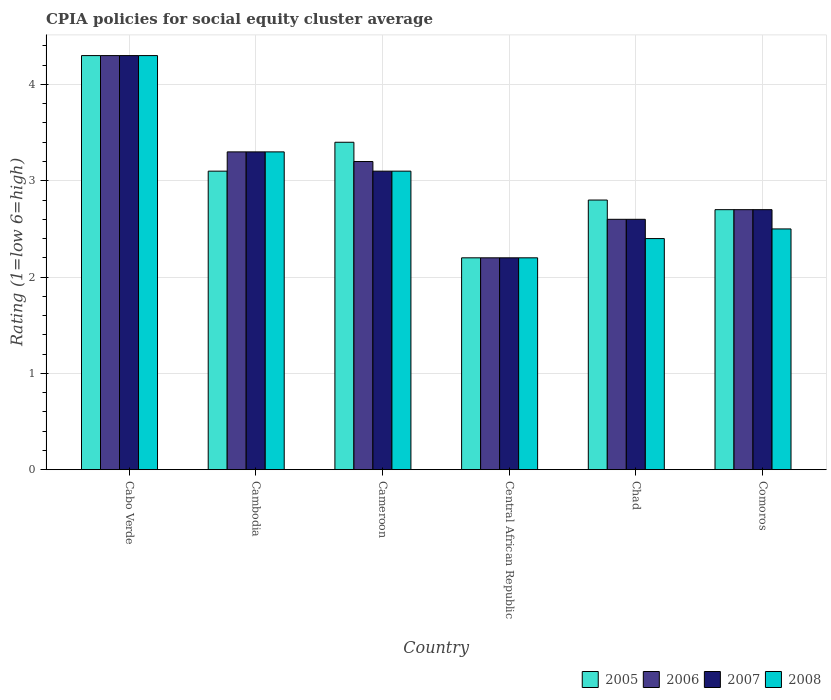How many different coloured bars are there?
Provide a succinct answer. 4. How many groups of bars are there?
Provide a succinct answer. 6. Are the number of bars on each tick of the X-axis equal?
Your response must be concise. Yes. How many bars are there on the 2nd tick from the left?
Provide a succinct answer. 4. What is the label of the 6th group of bars from the left?
Keep it short and to the point. Comoros. Across all countries, what is the maximum CPIA rating in 2007?
Provide a succinct answer. 4.3. Across all countries, what is the minimum CPIA rating in 2008?
Keep it short and to the point. 2.2. In which country was the CPIA rating in 2005 maximum?
Your answer should be very brief. Cabo Verde. In which country was the CPIA rating in 2007 minimum?
Provide a succinct answer. Central African Republic. What is the difference between the CPIA rating in 2005 in Cabo Verde and that in Cambodia?
Give a very brief answer. 1.2. What is the difference between the CPIA rating in 2007 in Central African Republic and the CPIA rating in 2008 in Cambodia?
Give a very brief answer. -1.1. What is the average CPIA rating in 2007 per country?
Offer a terse response. 3.03. What is the difference between the CPIA rating of/in 2008 and CPIA rating of/in 2006 in Cameroon?
Provide a succinct answer. -0.1. What is the ratio of the CPIA rating in 2008 in Cambodia to that in Cameroon?
Your response must be concise. 1.06. What is the difference between the highest and the second highest CPIA rating in 2006?
Make the answer very short. -0.1. What is the difference between the highest and the lowest CPIA rating in 2008?
Offer a terse response. 2.1. In how many countries, is the CPIA rating in 2008 greater than the average CPIA rating in 2008 taken over all countries?
Offer a terse response. 3. Is the sum of the CPIA rating in 2007 in Cabo Verde and Cameroon greater than the maximum CPIA rating in 2005 across all countries?
Provide a short and direct response. Yes. Is it the case that in every country, the sum of the CPIA rating in 2007 and CPIA rating in 2006 is greater than the sum of CPIA rating in 2005 and CPIA rating in 2008?
Give a very brief answer. No. What does the 4th bar from the left in Cabo Verde represents?
Offer a terse response. 2008. Are all the bars in the graph horizontal?
Make the answer very short. No. What is the difference between two consecutive major ticks on the Y-axis?
Your response must be concise. 1. Where does the legend appear in the graph?
Provide a succinct answer. Bottom right. What is the title of the graph?
Provide a short and direct response. CPIA policies for social equity cluster average. Does "1966" appear as one of the legend labels in the graph?
Ensure brevity in your answer.  No. What is the label or title of the X-axis?
Your answer should be compact. Country. What is the Rating (1=low 6=high) of 2006 in Cabo Verde?
Your answer should be very brief. 4.3. What is the Rating (1=low 6=high) of 2006 in Cambodia?
Provide a short and direct response. 3.3. What is the Rating (1=low 6=high) in 2007 in Cambodia?
Your answer should be very brief. 3.3. What is the Rating (1=low 6=high) in 2008 in Cameroon?
Your answer should be compact. 3.1. What is the Rating (1=low 6=high) of 2005 in Central African Republic?
Your response must be concise. 2.2. What is the Rating (1=low 6=high) of 2006 in Central African Republic?
Offer a terse response. 2.2. What is the Rating (1=low 6=high) of 2005 in Chad?
Your answer should be compact. 2.8. What is the Rating (1=low 6=high) in 2006 in Chad?
Keep it short and to the point. 2.6. What is the Rating (1=low 6=high) in 2007 in Comoros?
Your answer should be compact. 2.7. What is the Rating (1=low 6=high) of 2008 in Comoros?
Your answer should be very brief. 2.5. Across all countries, what is the maximum Rating (1=low 6=high) in 2005?
Your answer should be compact. 4.3. Across all countries, what is the maximum Rating (1=low 6=high) of 2006?
Your response must be concise. 4.3. Across all countries, what is the maximum Rating (1=low 6=high) in 2007?
Your answer should be very brief. 4.3. Across all countries, what is the maximum Rating (1=low 6=high) in 2008?
Your answer should be very brief. 4.3. Across all countries, what is the minimum Rating (1=low 6=high) in 2005?
Provide a short and direct response. 2.2. Across all countries, what is the minimum Rating (1=low 6=high) in 2006?
Your response must be concise. 2.2. Across all countries, what is the minimum Rating (1=low 6=high) in 2007?
Your answer should be compact. 2.2. What is the total Rating (1=low 6=high) in 2005 in the graph?
Offer a terse response. 18.5. What is the total Rating (1=low 6=high) in 2006 in the graph?
Offer a very short reply. 18.3. What is the difference between the Rating (1=low 6=high) of 2006 in Cabo Verde and that in Cambodia?
Offer a very short reply. 1. What is the difference between the Rating (1=low 6=high) of 2007 in Cabo Verde and that in Cambodia?
Give a very brief answer. 1. What is the difference between the Rating (1=low 6=high) in 2005 in Cabo Verde and that in Cameroon?
Ensure brevity in your answer.  0.9. What is the difference between the Rating (1=low 6=high) of 2006 in Cabo Verde and that in Cameroon?
Your answer should be compact. 1.1. What is the difference between the Rating (1=low 6=high) in 2008 in Cabo Verde and that in Cameroon?
Give a very brief answer. 1.2. What is the difference between the Rating (1=low 6=high) in 2005 in Cabo Verde and that in Central African Republic?
Your answer should be very brief. 2.1. What is the difference between the Rating (1=low 6=high) of 2006 in Cabo Verde and that in Central African Republic?
Give a very brief answer. 2.1. What is the difference between the Rating (1=low 6=high) of 2007 in Cabo Verde and that in Central African Republic?
Provide a short and direct response. 2.1. What is the difference between the Rating (1=low 6=high) in 2005 in Cabo Verde and that in Chad?
Your answer should be compact. 1.5. What is the difference between the Rating (1=low 6=high) of 2007 in Cabo Verde and that in Chad?
Provide a succinct answer. 1.7. What is the difference between the Rating (1=low 6=high) of 2008 in Cabo Verde and that in Chad?
Your answer should be compact. 1.9. What is the difference between the Rating (1=low 6=high) of 2005 in Cabo Verde and that in Comoros?
Offer a very short reply. 1.6. What is the difference between the Rating (1=low 6=high) of 2006 in Cabo Verde and that in Comoros?
Give a very brief answer. 1.6. What is the difference between the Rating (1=low 6=high) in 2007 in Cabo Verde and that in Comoros?
Your answer should be very brief. 1.6. What is the difference between the Rating (1=low 6=high) of 2008 in Cabo Verde and that in Comoros?
Provide a short and direct response. 1.8. What is the difference between the Rating (1=low 6=high) of 2007 in Cambodia and that in Cameroon?
Provide a short and direct response. 0.2. What is the difference between the Rating (1=low 6=high) in 2007 in Cambodia and that in Central African Republic?
Keep it short and to the point. 1.1. What is the difference between the Rating (1=low 6=high) of 2008 in Cambodia and that in Central African Republic?
Keep it short and to the point. 1.1. What is the difference between the Rating (1=low 6=high) in 2008 in Cambodia and that in Chad?
Offer a terse response. 0.9. What is the difference between the Rating (1=low 6=high) in 2005 in Cambodia and that in Comoros?
Give a very brief answer. 0.4. What is the difference between the Rating (1=low 6=high) in 2007 in Cambodia and that in Comoros?
Provide a succinct answer. 0.6. What is the difference between the Rating (1=low 6=high) of 2005 in Cameroon and that in Central African Republic?
Offer a terse response. 1.2. What is the difference between the Rating (1=low 6=high) in 2006 in Cameroon and that in Central African Republic?
Ensure brevity in your answer.  1. What is the difference between the Rating (1=low 6=high) in 2005 in Cameroon and that in Chad?
Offer a terse response. 0.6. What is the difference between the Rating (1=low 6=high) in 2008 in Cameroon and that in Chad?
Your answer should be compact. 0.7. What is the difference between the Rating (1=low 6=high) of 2005 in Cameroon and that in Comoros?
Provide a succinct answer. 0.7. What is the difference between the Rating (1=low 6=high) in 2006 in Cameroon and that in Comoros?
Your response must be concise. 0.5. What is the difference between the Rating (1=low 6=high) in 2008 in Cameroon and that in Comoros?
Your answer should be very brief. 0.6. What is the difference between the Rating (1=low 6=high) in 2006 in Central African Republic and that in Chad?
Offer a terse response. -0.4. What is the difference between the Rating (1=low 6=high) in 2007 in Central African Republic and that in Chad?
Make the answer very short. -0.4. What is the difference between the Rating (1=low 6=high) in 2006 in Central African Republic and that in Comoros?
Your response must be concise. -0.5. What is the difference between the Rating (1=low 6=high) in 2007 in Central African Republic and that in Comoros?
Provide a short and direct response. -0.5. What is the difference between the Rating (1=low 6=high) in 2008 in Central African Republic and that in Comoros?
Provide a succinct answer. -0.3. What is the difference between the Rating (1=low 6=high) in 2005 in Chad and that in Comoros?
Make the answer very short. 0.1. What is the difference between the Rating (1=low 6=high) in 2006 in Cabo Verde and the Rating (1=low 6=high) in 2007 in Cambodia?
Keep it short and to the point. 1. What is the difference between the Rating (1=low 6=high) of 2007 in Cabo Verde and the Rating (1=low 6=high) of 2008 in Cambodia?
Your answer should be very brief. 1. What is the difference between the Rating (1=low 6=high) in 2006 in Cabo Verde and the Rating (1=low 6=high) in 2007 in Cameroon?
Offer a very short reply. 1.2. What is the difference between the Rating (1=low 6=high) of 2005 in Cabo Verde and the Rating (1=low 6=high) of 2006 in Central African Republic?
Offer a terse response. 2.1. What is the difference between the Rating (1=low 6=high) in 2006 in Cabo Verde and the Rating (1=low 6=high) in 2007 in Central African Republic?
Offer a terse response. 2.1. What is the difference between the Rating (1=low 6=high) of 2005 in Cabo Verde and the Rating (1=low 6=high) of 2008 in Chad?
Your answer should be very brief. 1.9. What is the difference between the Rating (1=low 6=high) of 2006 in Cabo Verde and the Rating (1=low 6=high) of 2007 in Chad?
Ensure brevity in your answer.  1.7. What is the difference between the Rating (1=low 6=high) of 2005 in Cambodia and the Rating (1=low 6=high) of 2006 in Cameroon?
Provide a succinct answer. -0.1. What is the difference between the Rating (1=low 6=high) in 2005 in Cambodia and the Rating (1=low 6=high) in 2007 in Cameroon?
Provide a succinct answer. 0. What is the difference between the Rating (1=low 6=high) in 2007 in Cambodia and the Rating (1=low 6=high) in 2008 in Cameroon?
Your answer should be very brief. 0.2. What is the difference between the Rating (1=low 6=high) of 2005 in Cambodia and the Rating (1=low 6=high) of 2006 in Central African Republic?
Make the answer very short. 0.9. What is the difference between the Rating (1=low 6=high) in 2005 in Cambodia and the Rating (1=low 6=high) in 2008 in Central African Republic?
Your response must be concise. 0.9. What is the difference between the Rating (1=low 6=high) of 2006 in Cambodia and the Rating (1=low 6=high) of 2007 in Chad?
Offer a very short reply. 0.7. What is the difference between the Rating (1=low 6=high) of 2007 in Cambodia and the Rating (1=low 6=high) of 2008 in Chad?
Offer a terse response. 0.9. What is the difference between the Rating (1=low 6=high) of 2005 in Cambodia and the Rating (1=low 6=high) of 2006 in Comoros?
Provide a short and direct response. 0.4. What is the difference between the Rating (1=low 6=high) in 2005 in Cambodia and the Rating (1=low 6=high) in 2007 in Comoros?
Offer a terse response. 0.4. What is the difference between the Rating (1=low 6=high) of 2005 in Cambodia and the Rating (1=low 6=high) of 2008 in Comoros?
Your response must be concise. 0.6. What is the difference between the Rating (1=low 6=high) of 2006 in Cambodia and the Rating (1=low 6=high) of 2007 in Comoros?
Your answer should be compact. 0.6. What is the difference between the Rating (1=low 6=high) in 2007 in Cambodia and the Rating (1=low 6=high) in 2008 in Comoros?
Your answer should be very brief. 0.8. What is the difference between the Rating (1=low 6=high) of 2006 in Cameroon and the Rating (1=low 6=high) of 2008 in Central African Republic?
Offer a terse response. 1. What is the difference between the Rating (1=low 6=high) of 2007 in Cameroon and the Rating (1=low 6=high) of 2008 in Central African Republic?
Your response must be concise. 0.9. What is the difference between the Rating (1=low 6=high) of 2005 in Cameroon and the Rating (1=low 6=high) of 2006 in Chad?
Ensure brevity in your answer.  0.8. What is the difference between the Rating (1=low 6=high) in 2006 in Cameroon and the Rating (1=low 6=high) in 2008 in Chad?
Offer a terse response. 0.8. What is the difference between the Rating (1=low 6=high) of 2007 in Cameroon and the Rating (1=low 6=high) of 2008 in Chad?
Provide a succinct answer. 0.7. What is the difference between the Rating (1=low 6=high) of 2005 in Cameroon and the Rating (1=low 6=high) of 2006 in Comoros?
Provide a succinct answer. 0.7. What is the difference between the Rating (1=low 6=high) in 2005 in Cameroon and the Rating (1=low 6=high) in 2007 in Comoros?
Your answer should be very brief. 0.7. What is the difference between the Rating (1=low 6=high) in 2005 in Cameroon and the Rating (1=low 6=high) in 2008 in Comoros?
Your answer should be compact. 0.9. What is the difference between the Rating (1=low 6=high) of 2006 in Cameroon and the Rating (1=low 6=high) of 2007 in Comoros?
Your response must be concise. 0.5. What is the difference between the Rating (1=low 6=high) in 2006 in Cameroon and the Rating (1=low 6=high) in 2008 in Comoros?
Your response must be concise. 0.7. What is the difference between the Rating (1=low 6=high) of 2007 in Central African Republic and the Rating (1=low 6=high) of 2008 in Chad?
Provide a succinct answer. -0.2. What is the difference between the Rating (1=low 6=high) in 2005 in Central African Republic and the Rating (1=low 6=high) in 2007 in Comoros?
Offer a terse response. -0.5. What is the difference between the Rating (1=low 6=high) of 2005 in Central African Republic and the Rating (1=low 6=high) of 2008 in Comoros?
Your answer should be very brief. -0.3. What is the difference between the Rating (1=low 6=high) in 2006 in Central African Republic and the Rating (1=low 6=high) in 2008 in Comoros?
Offer a very short reply. -0.3. What is the difference between the Rating (1=low 6=high) in 2007 in Central African Republic and the Rating (1=low 6=high) in 2008 in Comoros?
Ensure brevity in your answer.  -0.3. What is the difference between the Rating (1=low 6=high) of 2005 in Chad and the Rating (1=low 6=high) of 2006 in Comoros?
Offer a very short reply. 0.1. What is the difference between the Rating (1=low 6=high) in 2005 in Chad and the Rating (1=low 6=high) in 2007 in Comoros?
Ensure brevity in your answer.  0.1. What is the difference between the Rating (1=low 6=high) of 2005 in Chad and the Rating (1=low 6=high) of 2008 in Comoros?
Give a very brief answer. 0.3. What is the difference between the Rating (1=low 6=high) in 2006 in Chad and the Rating (1=low 6=high) in 2007 in Comoros?
Offer a terse response. -0.1. What is the difference between the Rating (1=low 6=high) of 2007 in Chad and the Rating (1=low 6=high) of 2008 in Comoros?
Offer a very short reply. 0.1. What is the average Rating (1=low 6=high) of 2005 per country?
Ensure brevity in your answer.  3.08. What is the average Rating (1=low 6=high) of 2006 per country?
Offer a terse response. 3.05. What is the average Rating (1=low 6=high) of 2007 per country?
Provide a short and direct response. 3.03. What is the average Rating (1=low 6=high) of 2008 per country?
Ensure brevity in your answer.  2.97. What is the difference between the Rating (1=low 6=high) in 2005 and Rating (1=low 6=high) in 2006 in Cabo Verde?
Provide a succinct answer. 0. What is the difference between the Rating (1=low 6=high) in 2005 and Rating (1=low 6=high) in 2008 in Cabo Verde?
Offer a very short reply. 0. What is the difference between the Rating (1=low 6=high) in 2006 and Rating (1=low 6=high) in 2007 in Cabo Verde?
Your response must be concise. 0. What is the difference between the Rating (1=low 6=high) of 2005 and Rating (1=low 6=high) of 2006 in Cambodia?
Your answer should be very brief. -0.2. What is the difference between the Rating (1=low 6=high) in 2007 and Rating (1=low 6=high) in 2008 in Cambodia?
Your answer should be very brief. 0. What is the difference between the Rating (1=low 6=high) of 2005 and Rating (1=low 6=high) of 2006 in Cameroon?
Your answer should be very brief. 0.2. What is the difference between the Rating (1=low 6=high) in 2005 and Rating (1=low 6=high) in 2008 in Cameroon?
Provide a succinct answer. 0.3. What is the difference between the Rating (1=low 6=high) of 2006 and Rating (1=low 6=high) of 2008 in Cameroon?
Ensure brevity in your answer.  0.1. What is the difference between the Rating (1=low 6=high) in 2005 and Rating (1=low 6=high) in 2007 in Central African Republic?
Offer a terse response. 0. What is the difference between the Rating (1=low 6=high) of 2005 and Rating (1=low 6=high) of 2008 in Central African Republic?
Your answer should be very brief. 0. What is the difference between the Rating (1=low 6=high) in 2006 and Rating (1=low 6=high) in 2007 in Central African Republic?
Offer a very short reply. 0. What is the difference between the Rating (1=low 6=high) in 2005 and Rating (1=low 6=high) in 2007 in Chad?
Provide a short and direct response. 0.2. What is the difference between the Rating (1=low 6=high) of 2007 and Rating (1=low 6=high) of 2008 in Chad?
Offer a terse response. 0.2. What is the difference between the Rating (1=low 6=high) of 2005 and Rating (1=low 6=high) of 2006 in Comoros?
Make the answer very short. 0. What is the difference between the Rating (1=low 6=high) of 2005 and Rating (1=low 6=high) of 2008 in Comoros?
Make the answer very short. 0.2. What is the difference between the Rating (1=low 6=high) of 2006 and Rating (1=low 6=high) of 2007 in Comoros?
Offer a very short reply. 0. What is the ratio of the Rating (1=low 6=high) of 2005 in Cabo Verde to that in Cambodia?
Ensure brevity in your answer.  1.39. What is the ratio of the Rating (1=low 6=high) in 2006 in Cabo Verde to that in Cambodia?
Offer a very short reply. 1.3. What is the ratio of the Rating (1=low 6=high) of 2007 in Cabo Verde to that in Cambodia?
Give a very brief answer. 1.3. What is the ratio of the Rating (1=low 6=high) of 2008 in Cabo Verde to that in Cambodia?
Provide a succinct answer. 1.3. What is the ratio of the Rating (1=low 6=high) of 2005 in Cabo Verde to that in Cameroon?
Keep it short and to the point. 1.26. What is the ratio of the Rating (1=low 6=high) in 2006 in Cabo Verde to that in Cameroon?
Offer a terse response. 1.34. What is the ratio of the Rating (1=low 6=high) of 2007 in Cabo Verde to that in Cameroon?
Offer a terse response. 1.39. What is the ratio of the Rating (1=low 6=high) in 2008 in Cabo Verde to that in Cameroon?
Ensure brevity in your answer.  1.39. What is the ratio of the Rating (1=low 6=high) of 2005 in Cabo Verde to that in Central African Republic?
Give a very brief answer. 1.95. What is the ratio of the Rating (1=low 6=high) of 2006 in Cabo Verde to that in Central African Republic?
Provide a succinct answer. 1.95. What is the ratio of the Rating (1=low 6=high) of 2007 in Cabo Verde to that in Central African Republic?
Offer a very short reply. 1.95. What is the ratio of the Rating (1=low 6=high) in 2008 in Cabo Verde to that in Central African Republic?
Give a very brief answer. 1.95. What is the ratio of the Rating (1=low 6=high) of 2005 in Cabo Verde to that in Chad?
Your answer should be compact. 1.54. What is the ratio of the Rating (1=low 6=high) in 2006 in Cabo Verde to that in Chad?
Make the answer very short. 1.65. What is the ratio of the Rating (1=low 6=high) of 2007 in Cabo Verde to that in Chad?
Offer a terse response. 1.65. What is the ratio of the Rating (1=low 6=high) in 2008 in Cabo Verde to that in Chad?
Offer a terse response. 1.79. What is the ratio of the Rating (1=low 6=high) in 2005 in Cabo Verde to that in Comoros?
Provide a succinct answer. 1.59. What is the ratio of the Rating (1=low 6=high) in 2006 in Cabo Verde to that in Comoros?
Provide a short and direct response. 1.59. What is the ratio of the Rating (1=low 6=high) of 2007 in Cabo Verde to that in Comoros?
Provide a short and direct response. 1.59. What is the ratio of the Rating (1=low 6=high) in 2008 in Cabo Verde to that in Comoros?
Give a very brief answer. 1.72. What is the ratio of the Rating (1=low 6=high) of 2005 in Cambodia to that in Cameroon?
Keep it short and to the point. 0.91. What is the ratio of the Rating (1=low 6=high) in 2006 in Cambodia to that in Cameroon?
Your response must be concise. 1.03. What is the ratio of the Rating (1=low 6=high) in 2007 in Cambodia to that in Cameroon?
Provide a succinct answer. 1.06. What is the ratio of the Rating (1=low 6=high) in 2008 in Cambodia to that in Cameroon?
Make the answer very short. 1.06. What is the ratio of the Rating (1=low 6=high) in 2005 in Cambodia to that in Central African Republic?
Offer a terse response. 1.41. What is the ratio of the Rating (1=low 6=high) of 2006 in Cambodia to that in Central African Republic?
Your response must be concise. 1.5. What is the ratio of the Rating (1=low 6=high) of 2005 in Cambodia to that in Chad?
Offer a terse response. 1.11. What is the ratio of the Rating (1=low 6=high) of 2006 in Cambodia to that in Chad?
Offer a terse response. 1.27. What is the ratio of the Rating (1=low 6=high) of 2007 in Cambodia to that in Chad?
Offer a very short reply. 1.27. What is the ratio of the Rating (1=low 6=high) in 2008 in Cambodia to that in Chad?
Offer a very short reply. 1.38. What is the ratio of the Rating (1=low 6=high) in 2005 in Cambodia to that in Comoros?
Provide a succinct answer. 1.15. What is the ratio of the Rating (1=low 6=high) of 2006 in Cambodia to that in Comoros?
Your response must be concise. 1.22. What is the ratio of the Rating (1=low 6=high) in 2007 in Cambodia to that in Comoros?
Give a very brief answer. 1.22. What is the ratio of the Rating (1=low 6=high) of 2008 in Cambodia to that in Comoros?
Give a very brief answer. 1.32. What is the ratio of the Rating (1=low 6=high) of 2005 in Cameroon to that in Central African Republic?
Give a very brief answer. 1.55. What is the ratio of the Rating (1=low 6=high) of 2006 in Cameroon to that in Central African Republic?
Give a very brief answer. 1.45. What is the ratio of the Rating (1=low 6=high) of 2007 in Cameroon to that in Central African Republic?
Ensure brevity in your answer.  1.41. What is the ratio of the Rating (1=low 6=high) in 2008 in Cameroon to that in Central African Republic?
Give a very brief answer. 1.41. What is the ratio of the Rating (1=low 6=high) of 2005 in Cameroon to that in Chad?
Provide a short and direct response. 1.21. What is the ratio of the Rating (1=low 6=high) of 2006 in Cameroon to that in Chad?
Ensure brevity in your answer.  1.23. What is the ratio of the Rating (1=low 6=high) in 2007 in Cameroon to that in Chad?
Offer a terse response. 1.19. What is the ratio of the Rating (1=low 6=high) of 2008 in Cameroon to that in Chad?
Provide a succinct answer. 1.29. What is the ratio of the Rating (1=low 6=high) of 2005 in Cameroon to that in Comoros?
Give a very brief answer. 1.26. What is the ratio of the Rating (1=low 6=high) in 2006 in Cameroon to that in Comoros?
Your answer should be compact. 1.19. What is the ratio of the Rating (1=low 6=high) of 2007 in Cameroon to that in Comoros?
Offer a very short reply. 1.15. What is the ratio of the Rating (1=low 6=high) of 2008 in Cameroon to that in Comoros?
Provide a succinct answer. 1.24. What is the ratio of the Rating (1=low 6=high) of 2005 in Central African Republic to that in Chad?
Your response must be concise. 0.79. What is the ratio of the Rating (1=low 6=high) of 2006 in Central African Republic to that in Chad?
Keep it short and to the point. 0.85. What is the ratio of the Rating (1=low 6=high) of 2007 in Central African Republic to that in Chad?
Give a very brief answer. 0.85. What is the ratio of the Rating (1=low 6=high) of 2008 in Central African Republic to that in Chad?
Ensure brevity in your answer.  0.92. What is the ratio of the Rating (1=low 6=high) of 2005 in Central African Republic to that in Comoros?
Your answer should be compact. 0.81. What is the ratio of the Rating (1=low 6=high) of 2006 in Central African Republic to that in Comoros?
Ensure brevity in your answer.  0.81. What is the ratio of the Rating (1=low 6=high) in 2007 in Central African Republic to that in Comoros?
Provide a short and direct response. 0.81. What is the ratio of the Rating (1=low 6=high) in 2005 in Chad to that in Comoros?
Provide a succinct answer. 1.04. What is the ratio of the Rating (1=low 6=high) of 2007 in Chad to that in Comoros?
Your answer should be compact. 0.96. What is the difference between the highest and the second highest Rating (1=low 6=high) in 2005?
Give a very brief answer. 0.9. What is the difference between the highest and the lowest Rating (1=low 6=high) in 2006?
Offer a very short reply. 2.1. 